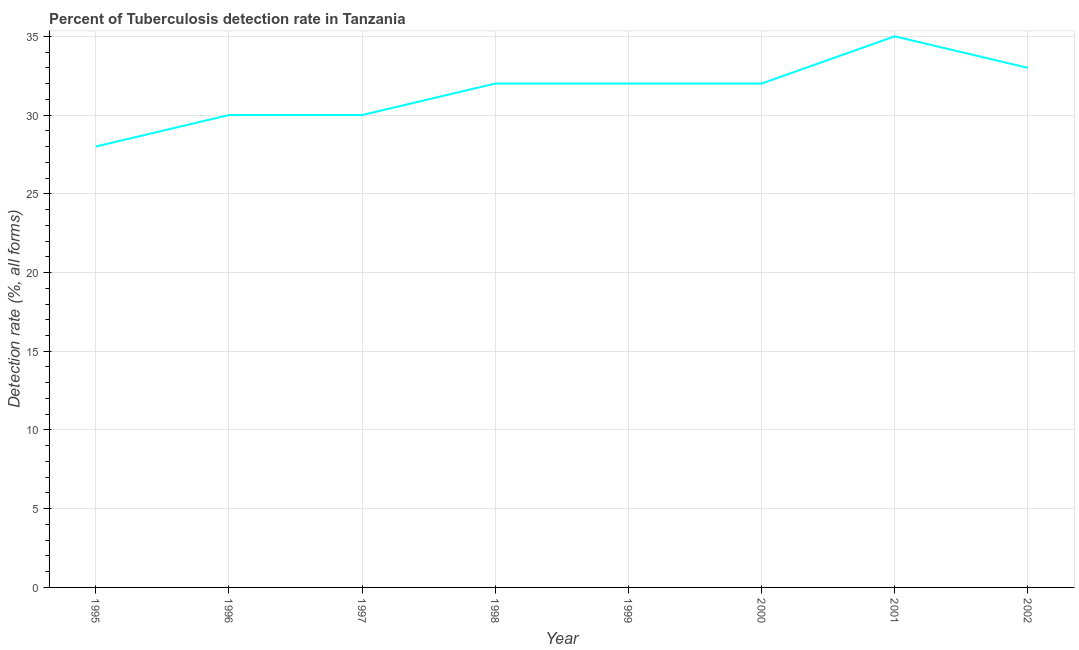What is the detection rate of tuberculosis in 1997?
Offer a terse response. 30. Across all years, what is the maximum detection rate of tuberculosis?
Keep it short and to the point. 35. Across all years, what is the minimum detection rate of tuberculosis?
Provide a succinct answer. 28. What is the sum of the detection rate of tuberculosis?
Give a very brief answer. 252. What is the difference between the detection rate of tuberculosis in 1998 and 2002?
Provide a short and direct response. -1. What is the average detection rate of tuberculosis per year?
Make the answer very short. 31.5. What is the median detection rate of tuberculosis?
Offer a terse response. 32. In how many years, is the detection rate of tuberculosis greater than 20 %?
Your answer should be very brief. 8. Do a majority of the years between 1999 and 2000 (inclusive) have detection rate of tuberculosis greater than 30 %?
Offer a very short reply. Yes. Is the detection rate of tuberculosis in 1997 less than that in 2000?
Provide a short and direct response. Yes. Is the difference between the detection rate of tuberculosis in 1996 and 1999 greater than the difference between any two years?
Offer a terse response. No. What is the difference between the highest and the second highest detection rate of tuberculosis?
Make the answer very short. 2. Is the sum of the detection rate of tuberculosis in 1996 and 1998 greater than the maximum detection rate of tuberculosis across all years?
Provide a succinct answer. Yes. What is the difference between the highest and the lowest detection rate of tuberculosis?
Ensure brevity in your answer.  7. In how many years, is the detection rate of tuberculosis greater than the average detection rate of tuberculosis taken over all years?
Ensure brevity in your answer.  5. Does the detection rate of tuberculosis monotonically increase over the years?
Your response must be concise. No. What is the difference between two consecutive major ticks on the Y-axis?
Ensure brevity in your answer.  5. Does the graph contain any zero values?
Offer a very short reply. No. What is the title of the graph?
Offer a terse response. Percent of Tuberculosis detection rate in Tanzania. What is the label or title of the X-axis?
Give a very brief answer. Year. What is the label or title of the Y-axis?
Keep it short and to the point. Detection rate (%, all forms). What is the Detection rate (%, all forms) in 1995?
Offer a terse response. 28. What is the Detection rate (%, all forms) in 1996?
Offer a terse response. 30. What is the Detection rate (%, all forms) of 1997?
Offer a terse response. 30. What is the Detection rate (%, all forms) in 1999?
Keep it short and to the point. 32. What is the Detection rate (%, all forms) in 2001?
Provide a short and direct response. 35. What is the Detection rate (%, all forms) in 2002?
Keep it short and to the point. 33. What is the difference between the Detection rate (%, all forms) in 1995 and 1996?
Your answer should be very brief. -2. What is the difference between the Detection rate (%, all forms) in 1995 and 1998?
Give a very brief answer. -4. What is the difference between the Detection rate (%, all forms) in 1995 and 2000?
Provide a short and direct response. -4. What is the difference between the Detection rate (%, all forms) in 1996 and 1997?
Offer a very short reply. 0. What is the difference between the Detection rate (%, all forms) in 1996 and 1998?
Your response must be concise. -2. What is the difference between the Detection rate (%, all forms) in 1996 and 2001?
Your answer should be very brief. -5. What is the difference between the Detection rate (%, all forms) in 1997 and 2001?
Offer a terse response. -5. What is the difference between the Detection rate (%, all forms) in 1998 and 1999?
Offer a very short reply. 0. What is the difference between the Detection rate (%, all forms) in 1998 and 2000?
Your answer should be very brief. 0. What is the difference between the Detection rate (%, all forms) in 1998 and 2001?
Provide a succinct answer. -3. What is the difference between the Detection rate (%, all forms) in 1999 and 2002?
Your response must be concise. -1. What is the difference between the Detection rate (%, all forms) in 2000 and 2001?
Ensure brevity in your answer.  -3. What is the difference between the Detection rate (%, all forms) in 2000 and 2002?
Offer a very short reply. -1. What is the difference between the Detection rate (%, all forms) in 2001 and 2002?
Your response must be concise. 2. What is the ratio of the Detection rate (%, all forms) in 1995 to that in 1996?
Offer a terse response. 0.93. What is the ratio of the Detection rate (%, all forms) in 1995 to that in 1997?
Your response must be concise. 0.93. What is the ratio of the Detection rate (%, all forms) in 1995 to that in 1999?
Provide a short and direct response. 0.88. What is the ratio of the Detection rate (%, all forms) in 1995 to that in 2001?
Provide a succinct answer. 0.8. What is the ratio of the Detection rate (%, all forms) in 1995 to that in 2002?
Your answer should be compact. 0.85. What is the ratio of the Detection rate (%, all forms) in 1996 to that in 1998?
Provide a succinct answer. 0.94. What is the ratio of the Detection rate (%, all forms) in 1996 to that in 1999?
Provide a short and direct response. 0.94. What is the ratio of the Detection rate (%, all forms) in 1996 to that in 2000?
Keep it short and to the point. 0.94. What is the ratio of the Detection rate (%, all forms) in 1996 to that in 2001?
Offer a terse response. 0.86. What is the ratio of the Detection rate (%, all forms) in 1996 to that in 2002?
Give a very brief answer. 0.91. What is the ratio of the Detection rate (%, all forms) in 1997 to that in 1998?
Make the answer very short. 0.94. What is the ratio of the Detection rate (%, all forms) in 1997 to that in 1999?
Make the answer very short. 0.94. What is the ratio of the Detection rate (%, all forms) in 1997 to that in 2000?
Offer a terse response. 0.94. What is the ratio of the Detection rate (%, all forms) in 1997 to that in 2001?
Offer a very short reply. 0.86. What is the ratio of the Detection rate (%, all forms) in 1997 to that in 2002?
Provide a succinct answer. 0.91. What is the ratio of the Detection rate (%, all forms) in 1998 to that in 2000?
Ensure brevity in your answer.  1. What is the ratio of the Detection rate (%, all forms) in 1998 to that in 2001?
Your answer should be very brief. 0.91. What is the ratio of the Detection rate (%, all forms) in 1999 to that in 2001?
Offer a very short reply. 0.91. What is the ratio of the Detection rate (%, all forms) in 2000 to that in 2001?
Make the answer very short. 0.91. What is the ratio of the Detection rate (%, all forms) in 2000 to that in 2002?
Make the answer very short. 0.97. What is the ratio of the Detection rate (%, all forms) in 2001 to that in 2002?
Offer a very short reply. 1.06. 